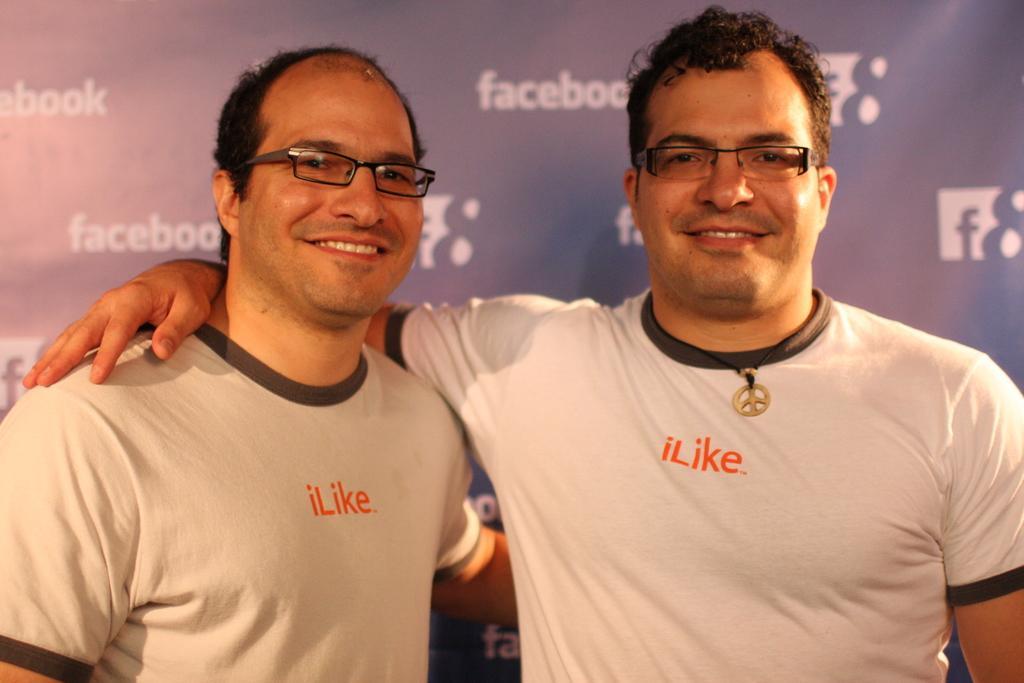Describe this image in one or two sentences. In this image we can see two persons smiling and we can see a poster with some text. 